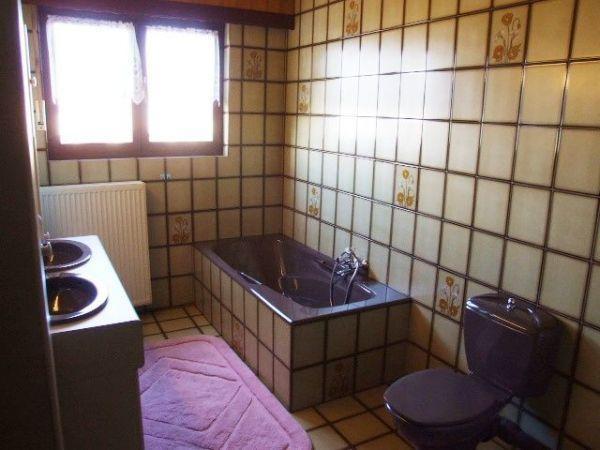What happens in this room?
Choose the right answer and clarify with the format: 'Answer: answer
Rationale: rationale.'
Options: Exercising, watching tv, washing hands, writing letters. Answer: washing hands.
Rationale: There is a sink with soap next to it. 